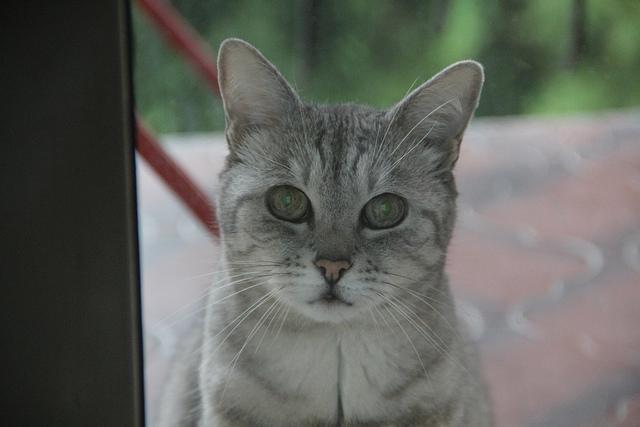How many cats are in the photo?
Give a very brief answer. 1. How many teddy bears are in the wagon?
Give a very brief answer. 0. 